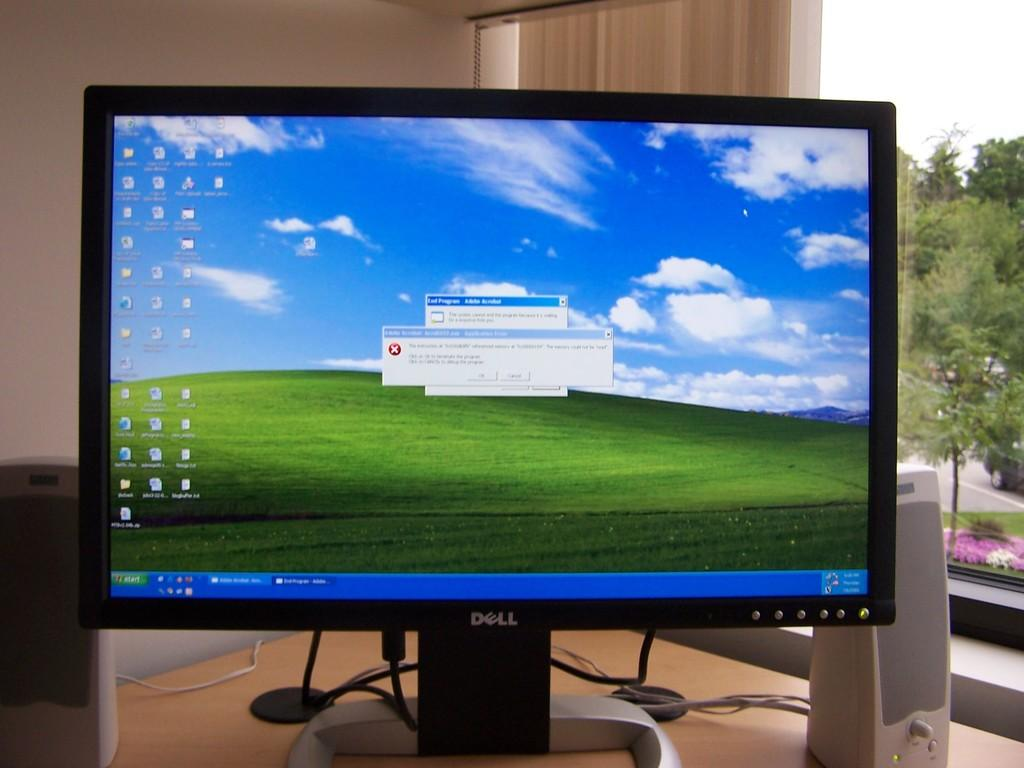<image>
Relay a brief, clear account of the picture shown. Dell monitor sits on a wooden table with an window behind it. 